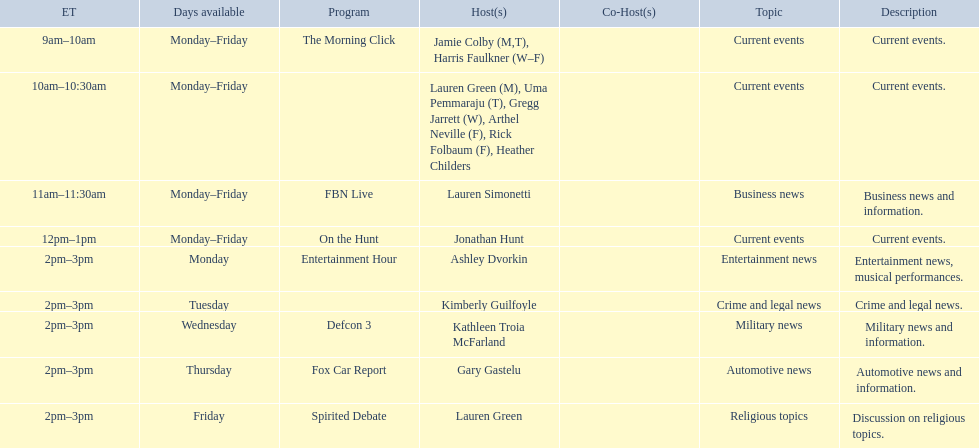What are the names of all the hosts? Jamie Colby (M,T), Harris Faulkner (W–F), Lauren Green (M), Uma Pemmaraju (T), Gregg Jarrett (W), Arthel Neville (F), Rick Folbaum (F), Heather Childers, Lauren Simonetti, Jonathan Hunt, Ashley Dvorkin, Kimberly Guilfoyle, Kathleen Troia McFarland, Gary Gastelu, Lauren Green. What hosts have a show on friday? Jamie Colby (M,T), Harris Faulkner (W–F), Lauren Green (M), Uma Pemmaraju (T), Gregg Jarrett (W), Arthel Neville (F), Rick Folbaum (F), Heather Childers, Lauren Simonetti, Jonathan Hunt, Lauren Green. Of these hosts, which is the only host with only friday available? Lauren Green. 